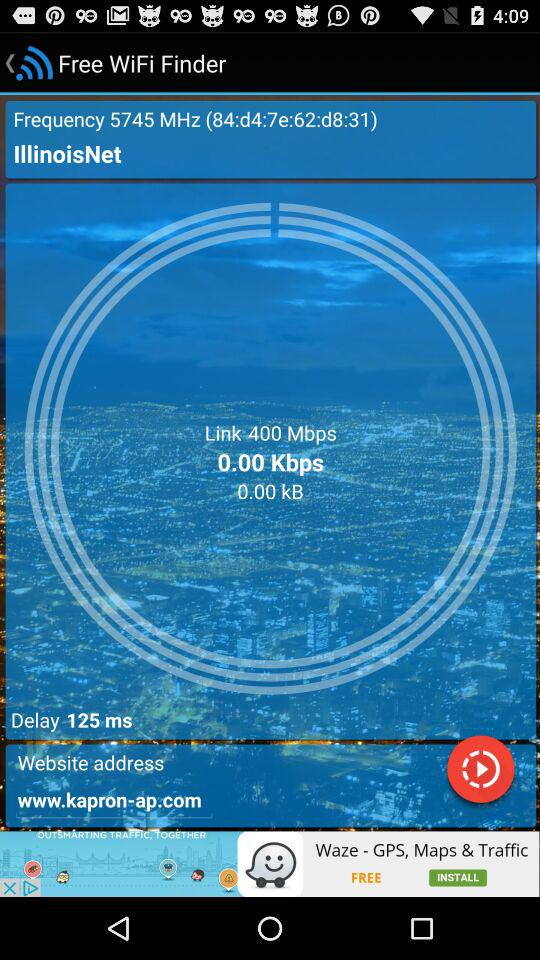Is the WiFi finder free or paid? The WiFi finder is free. 